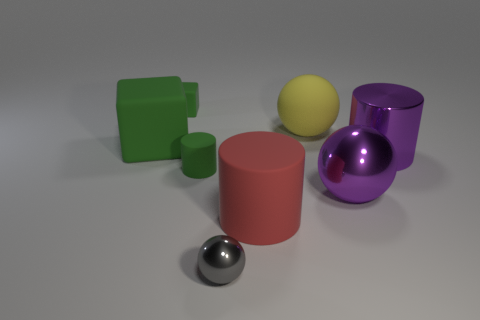What might be the size of these objects relative to each other? The cube and the two cylinders seem to be of comparable size, whereas the yellow sphere is slightly smaller. The purple sphere is the largest object, and the chrome sphere is the smallest amongst them. 